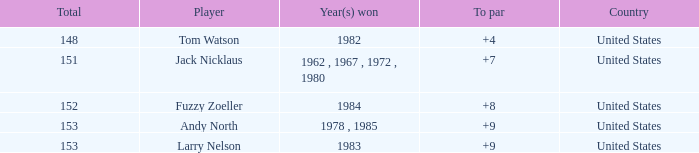What is the Country of the Player with a Total less than 153 and Year(s) won of 1984? United States. 